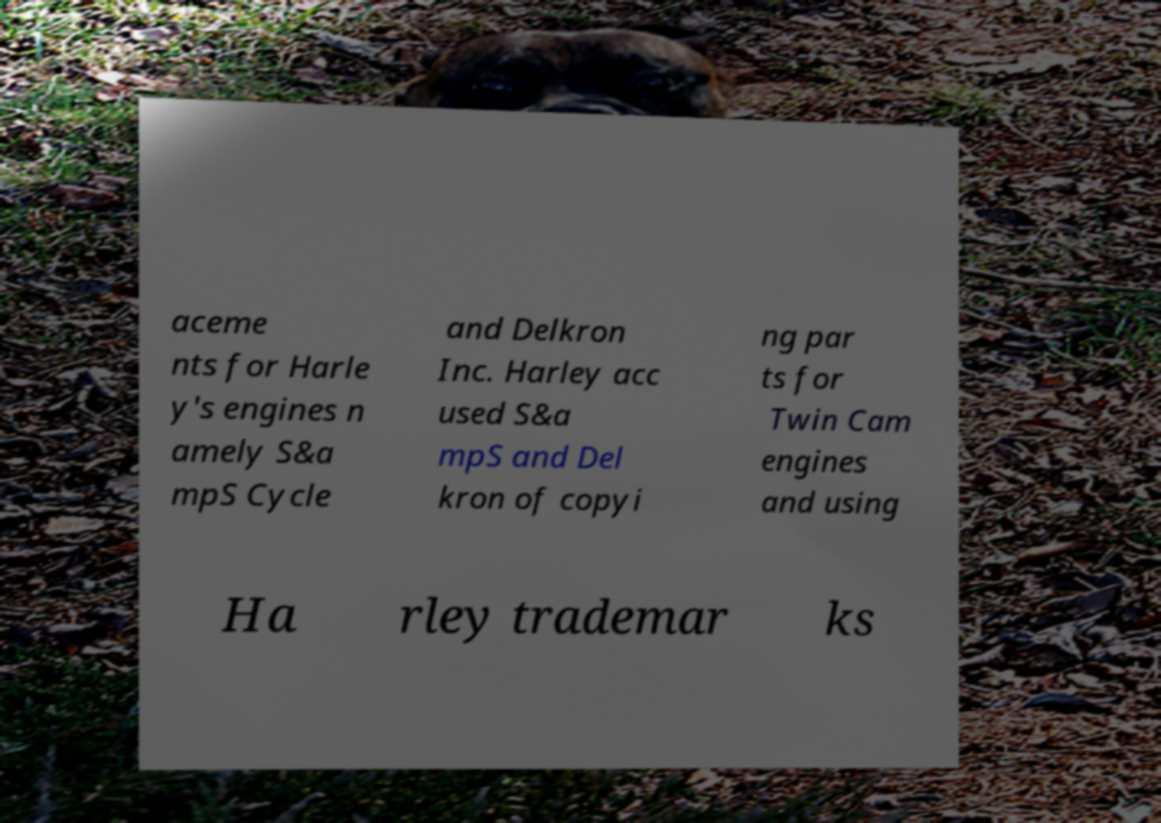Please identify and transcribe the text found in this image. aceme nts for Harle y's engines n amely S&a mpS Cycle and Delkron Inc. Harley acc used S&a mpS and Del kron of copyi ng par ts for Twin Cam engines and using Ha rley trademar ks 